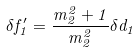<formula> <loc_0><loc_0><loc_500><loc_500>\delta f ^ { \prime } _ { 1 } = \frac { m _ { 2 } ^ { 2 } + 1 } { m _ { 2 } ^ { 2 } } \delta d _ { 1 }</formula> 